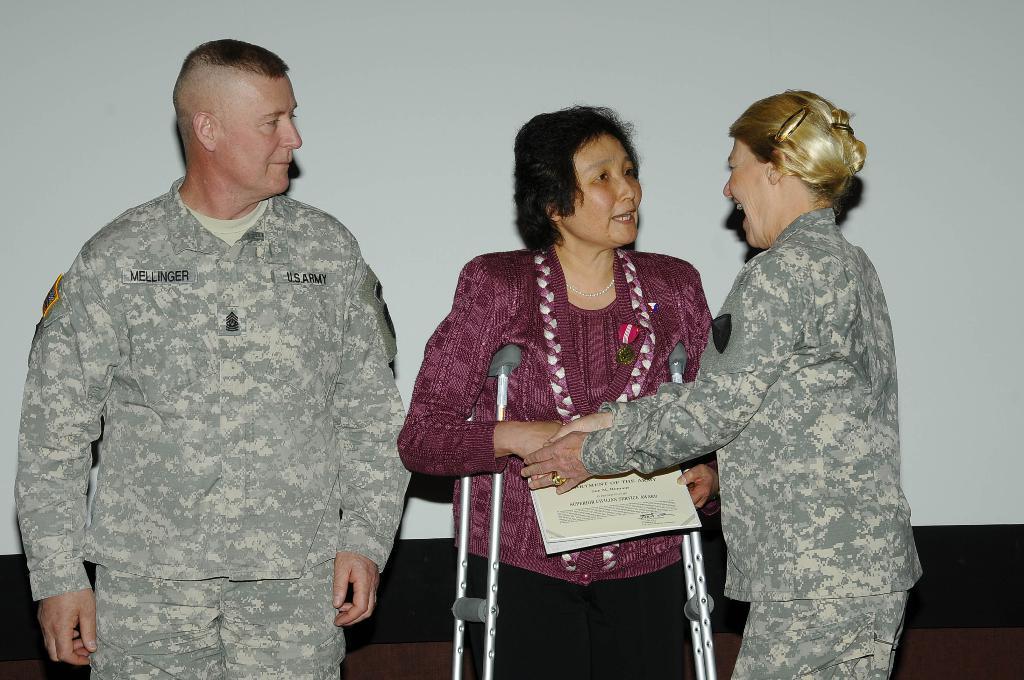Can you describe this image briefly? In this picture we can see two women and a man, the middle woman is standing with the help of sticks and she is holding papers. 